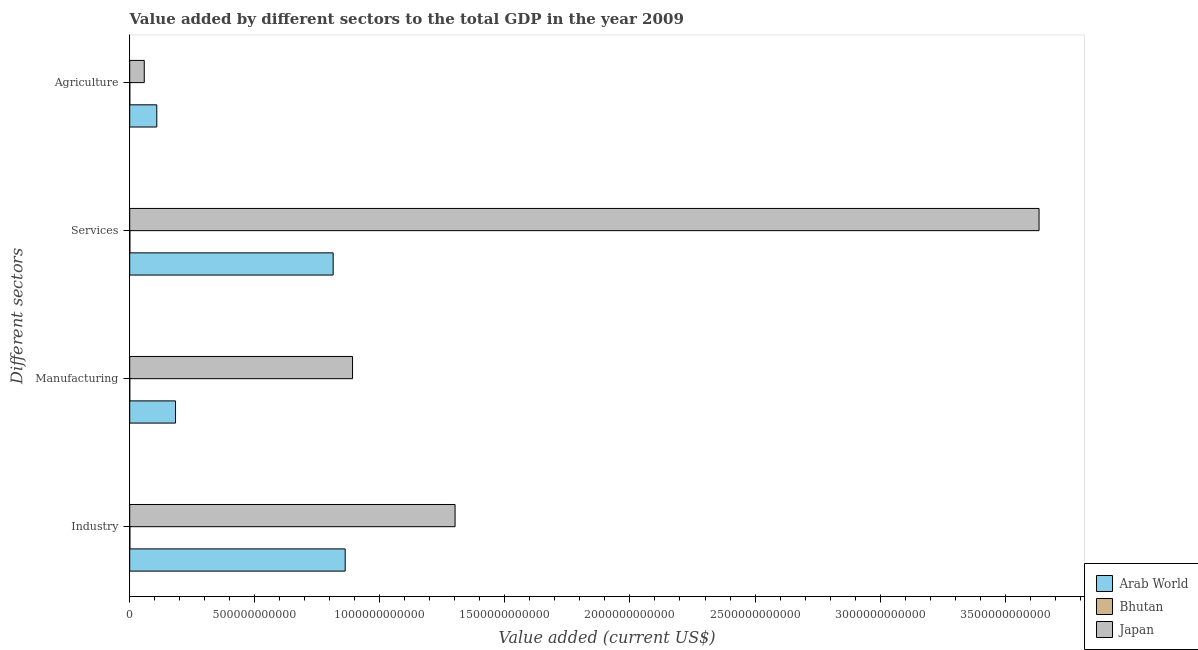How many different coloured bars are there?
Give a very brief answer. 3. How many bars are there on the 1st tick from the top?
Keep it short and to the point. 3. What is the label of the 1st group of bars from the top?
Provide a short and direct response. Agriculture. What is the value added by agricultural sector in Japan?
Your response must be concise. 5.81e+1. Across all countries, what is the maximum value added by industrial sector?
Give a very brief answer. 1.30e+12. Across all countries, what is the minimum value added by services sector?
Your answer should be very brief. 4.68e+08. In which country was the value added by industrial sector minimum?
Offer a terse response. Bhutan. What is the total value added by services sector in the graph?
Your answer should be very brief. 4.45e+12. What is the difference between the value added by industrial sector in Bhutan and that in Arab World?
Ensure brevity in your answer.  -8.61e+11. What is the difference between the value added by industrial sector in Arab World and the value added by services sector in Japan?
Your answer should be compact. -2.77e+12. What is the average value added by agricultural sector per country?
Give a very brief answer. 5.55e+1. What is the difference between the value added by industrial sector and value added by services sector in Arab World?
Your answer should be very brief. 4.81e+1. What is the ratio of the value added by manufacturing sector in Bhutan to that in Japan?
Your answer should be compact. 0. What is the difference between the highest and the second highest value added by manufacturing sector?
Keep it short and to the point. 7.08e+11. What is the difference between the highest and the lowest value added by agricultural sector?
Your answer should be very brief. 1.08e+11. Is it the case that in every country, the sum of the value added by agricultural sector and value added by industrial sector is greater than the sum of value added by services sector and value added by manufacturing sector?
Offer a terse response. No. What does the 3rd bar from the top in Manufacturing represents?
Your answer should be very brief. Arab World. What does the 2nd bar from the bottom in Manufacturing represents?
Provide a short and direct response. Bhutan. How many bars are there?
Provide a short and direct response. 12. Are all the bars in the graph horizontal?
Make the answer very short. Yes. How many countries are there in the graph?
Your response must be concise. 3. What is the difference between two consecutive major ticks on the X-axis?
Provide a short and direct response. 5.00e+11. Does the graph contain grids?
Your answer should be very brief. No. Where does the legend appear in the graph?
Offer a very short reply. Bottom right. How are the legend labels stacked?
Provide a short and direct response. Vertical. What is the title of the graph?
Offer a terse response. Value added by different sectors to the total GDP in the year 2009. What is the label or title of the X-axis?
Offer a terse response. Value added (current US$). What is the label or title of the Y-axis?
Your answer should be very brief. Different sectors. What is the Value added (current US$) in Arab World in Industry?
Provide a succinct answer. 8.61e+11. What is the Value added (current US$) in Bhutan in Industry?
Offer a very short reply. 5.31e+08. What is the Value added (current US$) in Japan in Industry?
Your answer should be very brief. 1.30e+12. What is the Value added (current US$) in Arab World in Manufacturing?
Offer a terse response. 1.83e+11. What is the Value added (current US$) in Bhutan in Manufacturing?
Make the answer very short. 1.04e+08. What is the Value added (current US$) of Japan in Manufacturing?
Provide a short and direct response. 8.91e+11. What is the Value added (current US$) of Arab World in Services?
Your answer should be very brief. 8.13e+11. What is the Value added (current US$) in Bhutan in Services?
Your response must be concise. 4.68e+08. What is the Value added (current US$) in Japan in Services?
Your response must be concise. 3.64e+12. What is the Value added (current US$) of Arab World in Agriculture?
Offer a terse response. 1.08e+11. What is the Value added (current US$) of Bhutan in Agriculture?
Your answer should be compact. 2.31e+08. What is the Value added (current US$) of Japan in Agriculture?
Your answer should be very brief. 5.81e+1. Across all Different sectors, what is the maximum Value added (current US$) of Arab World?
Provide a succinct answer. 8.61e+11. Across all Different sectors, what is the maximum Value added (current US$) in Bhutan?
Offer a very short reply. 5.31e+08. Across all Different sectors, what is the maximum Value added (current US$) in Japan?
Your answer should be compact. 3.64e+12. Across all Different sectors, what is the minimum Value added (current US$) in Arab World?
Your answer should be very brief. 1.08e+11. Across all Different sectors, what is the minimum Value added (current US$) of Bhutan?
Your response must be concise. 1.04e+08. Across all Different sectors, what is the minimum Value added (current US$) in Japan?
Offer a very short reply. 5.81e+1. What is the total Value added (current US$) in Arab World in the graph?
Make the answer very short. 1.97e+12. What is the total Value added (current US$) of Bhutan in the graph?
Give a very brief answer. 1.33e+09. What is the total Value added (current US$) of Japan in the graph?
Provide a succinct answer. 5.89e+12. What is the difference between the Value added (current US$) of Arab World in Industry and that in Manufacturing?
Ensure brevity in your answer.  6.78e+11. What is the difference between the Value added (current US$) in Bhutan in Industry and that in Manufacturing?
Your answer should be very brief. 4.27e+08. What is the difference between the Value added (current US$) of Japan in Industry and that in Manufacturing?
Offer a terse response. 4.10e+11. What is the difference between the Value added (current US$) in Arab World in Industry and that in Services?
Offer a very short reply. 4.81e+1. What is the difference between the Value added (current US$) in Bhutan in Industry and that in Services?
Make the answer very short. 6.25e+07. What is the difference between the Value added (current US$) of Japan in Industry and that in Services?
Offer a very short reply. -2.33e+12. What is the difference between the Value added (current US$) of Arab World in Industry and that in Agriculture?
Keep it short and to the point. 7.53e+11. What is the difference between the Value added (current US$) in Bhutan in Industry and that in Agriculture?
Offer a very short reply. 3.00e+08. What is the difference between the Value added (current US$) in Japan in Industry and that in Agriculture?
Give a very brief answer. 1.24e+12. What is the difference between the Value added (current US$) of Arab World in Manufacturing and that in Services?
Offer a very short reply. -6.30e+11. What is the difference between the Value added (current US$) in Bhutan in Manufacturing and that in Services?
Make the answer very short. -3.65e+08. What is the difference between the Value added (current US$) of Japan in Manufacturing and that in Services?
Provide a succinct answer. -2.74e+12. What is the difference between the Value added (current US$) of Arab World in Manufacturing and that in Agriculture?
Your answer should be compact. 7.49e+1. What is the difference between the Value added (current US$) in Bhutan in Manufacturing and that in Agriculture?
Provide a short and direct response. -1.27e+08. What is the difference between the Value added (current US$) in Japan in Manufacturing and that in Agriculture?
Ensure brevity in your answer.  8.33e+11. What is the difference between the Value added (current US$) in Arab World in Services and that in Agriculture?
Provide a succinct answer. 7.05e+11. What is the difference between the Value added (current US$) in Bhutan in Services and that in Agriculture?
Offer a terse response. 2.38e+08. What is the difference between the Value added (current US$) of Japan in Services and that in Agriculture?
Give a very brief answer. 3.58e+12. What is the difference between the Value added (current US$) in Arab World in Industry and the Value added (current US$) in Bhutan in Manufacturing?
Keep it short and to the point. 8.61e+11. What is the difference between the Value added (current US$) in Arab World in Industry and the Value added (current US$) in Japan in Manufacturing?
Give a very brief answer. -2.93e+1. What is the difference between the Value added (current US$) in Bhutan in Industry and the Value added (current US$) in Japan in Manufacturing?
Offer a terse response. -8.90e+11. What is the difference between the Value added (current US$) of Arab World in Industry and the Value added (current US$) of Bhutan in Services?
Provide a succinct answer. 8.61e+11. What is the difference between the Value added (current US$) of Arab World in Industry and the Value added (current US$) of Japan in Services?
Keep it short and to the point. -2.77e+12. What is the difference between the Value added (current US$) in Bhutan in Industry and the Value added (current US$) in Japan in Services?
Offer a terse response. -3.64e+12. What is the difference between the Value added (current US$) in Arab World in Industry and the Value added (current US$) in Bhutan in Agriculture?
Your response must be concise. 8.61e+11. What is the difference between the Value added (current US$) of Arab World in Industry and the Value added (current US$) of Japan in Agriculture?
Give a very brief answer. 8.03e+11. What is the difference between the Value added (current US$) in Bhutan in Industry and the Value added (current US$) in Japan in Agriculture?
Ensure brevity in your answer.  -5.76e+1. What is the difference between the Value added (current US$) of Arab World in Manufacturing and the Value added (current US$) of Bhutan in Services?
Your answer should be very brief. 1.83e+11. What is the difference between the Value added (current US$) of Arab World in Manufacturing and the Value added (current US$) of Japan in Services?
Offer a terse response. -3.45e+12. What is the difference between the Value added (current US$) in Bhutan in Manufacturing and the Value added (current US$) in Japan in Services?
Make the answer very short. -3.64e+12. What is the difference between the Value added (current US$) in Arab World in Manufacturing and the Value added (current US$) in Bhutan in Agriculture?
Ensure brevity in your answer.  1.83e+11. What is the difference between the Value added (current US$) of Arab World in Manufacturing and the Value added (current US$) of Japan in Agriculture?
Keep it short and to the point. 1.25e+11. What is the difference between the Value added (current US$) in Bhutan in Manufacturing and the Value added (current US$) in Japan in Agriculture?
Provide a succinct answer. -5.80e+1. What is the difference between the Value added (current US$) in Arab World in Services and the Value added (current US$) in Bhutan in Agriculture?
Your answer should be very brief. 8.13e+11. What is the difference between the Value added (current US$) in Arab World in Services and the Value added (current US$) in Japan in Agriculture?
Give a very brief answer. 7.55e+11. What is the difference between the Value added (current US$) of Bhutan in Services and the Value added (current US$) of Japan in Agriculture?
Ensure brevity in your answer.  -5.77e+1. What is the average Value added (current US$) of Arab World per Different sectors?
Offer a very short reply. 4.92e+11. What is the average Value added (current US$) in Bhutan per Different sectors?
Offer a terse response. 3.33e+08. What is the average Value added (current US$) of Japan per Different sectors?
Keep it short and to the point. 1.47e+12. What is the difference between the Value added (current US$) of Arab World and Value added (current US$) of Bhutan in Industry?
Provide a short and direct response. 8.61e+11. What is the difference between the Value added (current US$) in Arab World and Value added (current US$) in Japan in Industry?
Offer a very short reply. -4.39e+11. What is the difference between the Value added (current US$) in Bhutan and Value added (current US$) in Japan in Industry?
Make the answer very short. -1.30e+12. What is the difference between the Value added (current US$) of Arab World and Value added (current US$) of Bhutan in Manufacturing?
Offer a terse response. 1.83e+11. What is the difference between the Value added (current US$) in Arab World and Value added (current US$) in Japan in Manufacturing?
Give a very brief answer. -7.08e+11. What is the difference between the Value added (current US$) of Bhutan and Value added (current US$) of Japan in Manufacturing?
Your answer should be very brief. -8.91e+11. What is the difference between the Value added (current US$) of Arab World and Value added (current US$) of Bhutan in Services?
Keep it short and to the point. 8.13e+11. What is the difference between the Value added (current US$) in Arab World and Value added (current US$) in Japan in Services?
Your response must be concise. -2.82e+12. What is the difference between the Value added (current US$) of Bhutan and Value added (current US$) of Japan in Services?
Provide a short and direct response. -3.64e+12. What is the difference between the Value added (current US$) in Arab World and Value added (current US$) in Bhutan in Agriculture?
Ensure brevity in your answer.  1.08e+11. What is the difference between the Value added (current US$) of Arab World and Value added (current US$) of Japan in Agriculture?
Your answer should be very brief. 5.01e+1. What is the difference between the Value added (current US$) of Bhutan and Value added (current US$) of Japan in Agriculture?
Give a very brief answer. -5.79e+1. What is the ratio of the Value added (current US$) of Arab World in Industry to that in Manufacturing?
Ensure brevity in your answer.  4.7. What is the ratio of the Value added (current US$) of Bhutan in Industry to that in Manufacturing?
Give a very brief answer. 5.12. What is the ratio of the Value added (current US$) of Japan in Industry to that in Manufacturing?
Your response must be concise. 1.46. What is the ratio of the Value added (current US$) of Arab World in Industry to that in Services?
Your answer should be compact. 1.06. What is the ratio of the Value added (current US$) in Bhutan in Industry to that in Services?
Ensure brevity in your answer.  1.13. What is the ratio of the Value added (current US$) of Japan in Industry to that in Services?
Offer a very short reply. 0.36. What is the ratio of the Value added (current US$) of Arab World in Industry to that in Agriculture?
Ensure brevity in your answer.  7.96. What is the ratio of the Value added (current US$) in Bhutan in Industry to that in Agriculture?
Offer a very short reply. 2.3. What is the ratio of the Value added (current US$) of Japan in Industry to that in Agriculture?
Offer a very short reply. 22.37. What is the ratio of the Value added (current US$) of Arab World in Manufacturing to that in Services?
Provide a short and direct response. 0.23. What is the ratio of the Value added (current US$) in Bhutan in Manufacturing to that in Services?
Provide a succinct answer. 0.22. What is the ratio of the Value added (current US$) of Japan in Manufacturing to that in Services?
Keep it short and to the point. 0.24. What is the ratio of the Value added (current US$) of Arab World in Manufacturing to that in Agriculture?
Provide a short and direct response. 1.69. What is the ratio of the Value added (current US$) of Bhutan in Manufacturing to that in Agriculture?
Keep it short and to the point. 0.45. What is the ratio of the Value added (current US$) of Japan in Manufacturing to that in Agriculture?
Ensure brevity in your answer.  15.32. What is the ratio of the Value added (current US$) in Arab World in Services to that in Agriculture?
Keep it short and to the point. 7.51. What is the ratio of the Value added (current US$) in Bhutan in Services to that in Agriculture?
Make the answer very short. 2.03. What is the ratio of the Value added (current US$) of Japan in Services to that in Agriculture?
Your answer should be compact. 62.53. What is the difference between the highest and the second highest Value added (current US$) in Arab World?
Offer a terse response. 4.81e+1. What is the difference between the highest and the second highest Value added (current US$) in Bhutan?
Your answer should be compact. 6.25e+07. What is the difference between the highest and the second highest Value added (current US$) in Japan?
Your answer should be very brief. 2.33e+12. What is the difference between the highest and the lowest Value added (current US$) of Arab World?
Make the answer very short. 7.53e+11. What is the difference between the highest and the lowest Value added (current US$) in Bhutan?
Give a very brief answer. 4.27e+08. What is the difference between the highest and the lowest Value added (current US$) of Japan?
Give a very brief answer. 3.58e+12. 